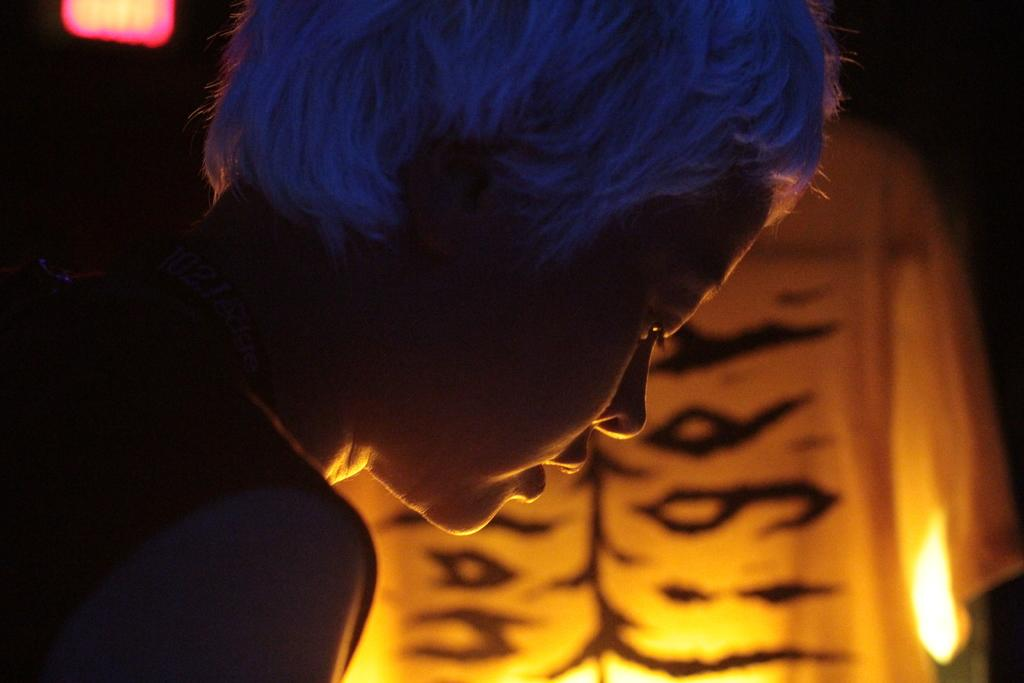Who is the main subject in the image? There is a lady in the image. What is the lady doing in the image? The lady is bending. What can be seen in the background of the image? There are lights and cloth in the background of the image. What type of record is the lady breaking in the image? There is no record being broken in the image; the lady is simply bending. What is the lady writing on in the image? There is no writing or writing surface present in the image. 